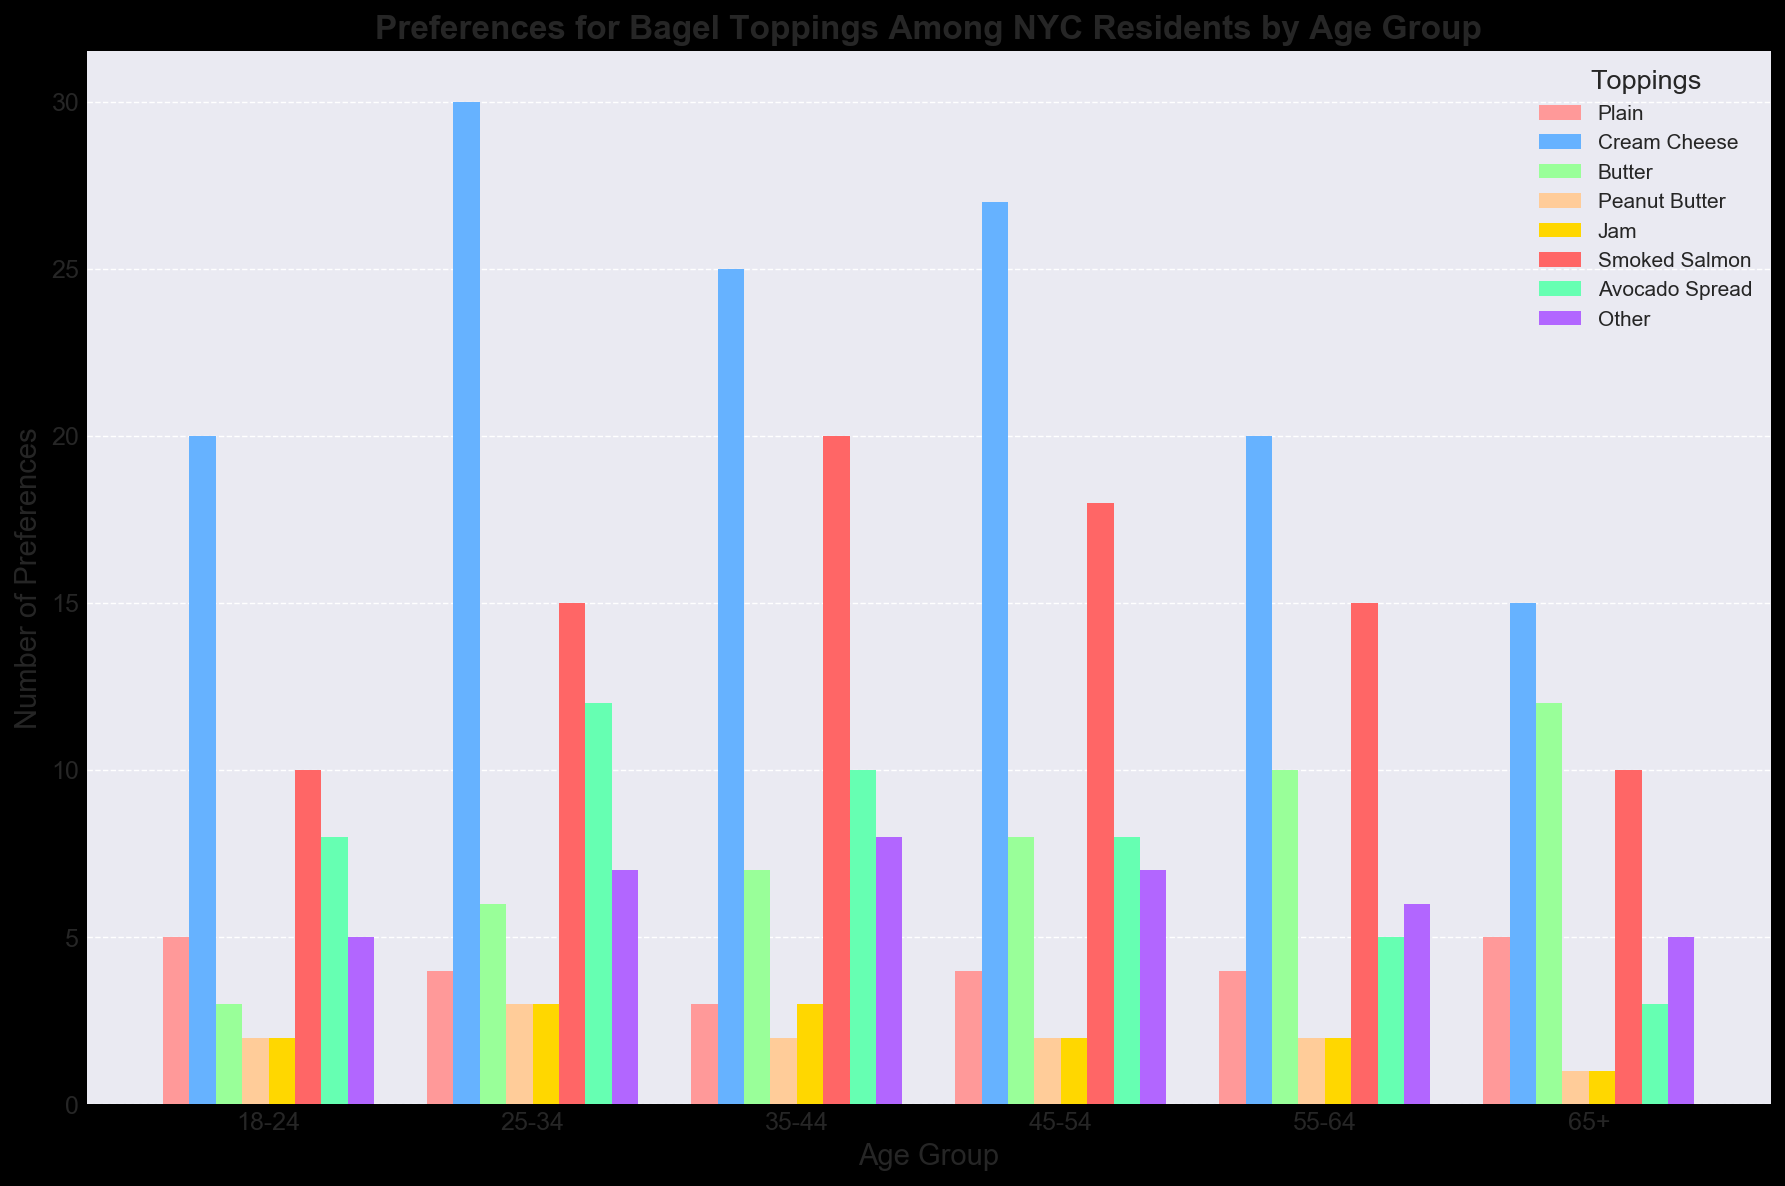Which age group prefers Plain bagels the most? Observe the height of the bars representing plain bagels across all age groups. The highest bar is for the age group 18-24.
Answer: 18-24 Which topping is the most popular among residents aged 25-34? Look at the bars for the 25-34 age group. The highest bar represents Cream Cheese.
Answer: Cream Cheese Which age group prefers Avocado Spread the least? Check the height of the Avocado Spread bars. The smallest bar is for the 65+ age group.
Answer: 65+ What is the total number of Butter preferences across all age groups? Sum the values for Butter in each age group: 3 + 6 + 7 + 8 + 10 + 12. The total is 46.
Answer: 46 How many more people in the 35-44 age group prefer Smoked Salmon compared to Peanut Butter? Subtract the number of preferences for Peanut Butter from Smoked Salmon in the 35-44 age group: 20 - 2 = 18.
Answer: 18 Which topping has the smallest difference in preference between the 18-24 and 65+ age groups? Calculate the absolute differences in preferences for each topping between the 18-24 and 65+ age groups and find the smallest value: Plain 0, Cream Cheese 5, Butter 9, Peanut Butter 1, Jam 1, Smoked Salmon 0, Avocado Spread 5, Other 0. The minimum difference is 0 for Plain, Smoked Salmon, and Other.
Answer: Plain, Smoked Salmon, Other Among the 45-54 age group, which topping has more preferences: Butter or Avocado Spread? Compare the heights of the bars for Butter and Avocado Spread in the 45-54 age group. Butter has 8 preferences and Avocado Spread has 8 as well.
Answer: Equal How many total preferences are there for 55-64 age group? Sum all preferences for the 55-64 age group: 4 (Plain) + 20 (Cream Cheese) + 10 (Butter) + 2 (Peanut Butter) + 2 (Jam) + 15 (Smoked Salmon) + 5 (Avocado Spread) + 6 (Other) = 64.
Answer: 64 